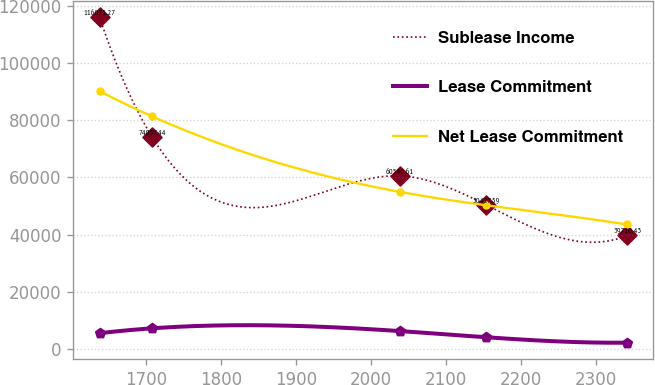Convert chart to OTSL. <chart><loc_0><loc_0><loc_500><loc_500><line_chart><ecel><fcel>Sublease Income<fcel>Lease Commitment<fcel>Net Lease Commitment<nl><fcel>1637.93<fcel>116075<fcel>5485.72<fcel>90211.8<nl><fcel>1708.3<fcel>74057.4<fcel>7208.28<fcel>81343.3<nl><fcel>2038.68<fcel>60540.6<fcel>6235.67<fcel>54941.3<nl><fcel>2153.27<fcel>50427.6<fcel>4086.46<fcel>50273.3<nl><fcel>2341.61<fcel>39710.4<fcel>2173.74<fcel>43531.7<nl></chart> 